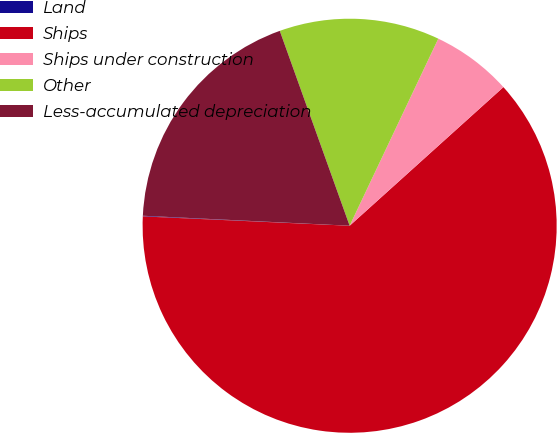Convert chart. <chart><loc_0><loc_0><loc_500><loc_500><pie_chart><fcel>Land<fcel>Ships<fcel>Ships under construction<fcel>Other<fcel>Less-accumulated depreciation<nl><fcel>0.05%<fcel>62.39%<fcel>6.28%<fcel>12.52%<fcel>18.75%<nl></chart> 